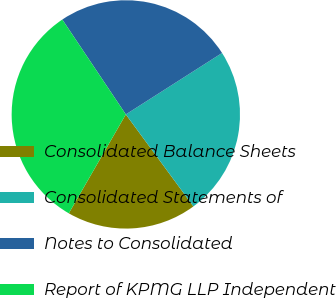Convert chart. <chart><loc_0><loc_0><loc_500><loc_500><pie_chart><fcel>Consolidated Balance Sheets<fcel>Consolidated Statements of<fcel>Notes to Consolidated<fcel>Report of KPMG LLP Independent<nl><fcel>18.41%<fcel>23.96%<fcel>25.35%<fcel>32.29%<nl></chart> 